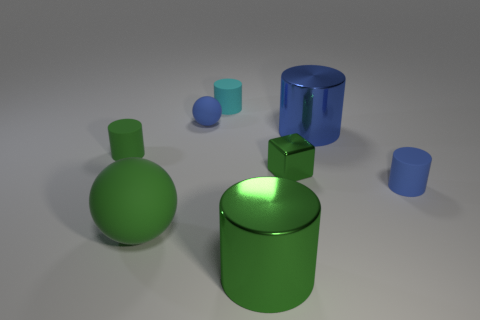Is there anything else that is the same shape as the small green metallic thing?
Make the answer very short. No. What number of blocks are either big blue shiny objects or shiny objects?
Your answer should be very brief. 1. What is the shape of the tiny green rubber object?
Provide a short and direct response. Cylinder. Are there any blue metallic things behind the cyan matte cylinder?
Ensure brevity in your answer.  No. Do the small cyan object and the small cylinder to the left of the cyan matte cylinder have the same material?
Your response must be concise. Yes. Does the big metal thing in front of the green rubber ball have the same shape as the large blue object?
Your answer should be very brief. Yes. What number of blocks are made of the same material as the big green sphere?
Make the answer very short. 0. How many objects are large cylinders that are right of the tiny green block or cyan matte cylinders?
Your answer should be very brief. 2. What size is the blue rubber sphere?
Offer a terse response. Small. What material is the tiny blue object on the left side of the matte cylinder that is behind the tiny blue rubber sphere made of?
Your answer should be very brief. Rubber. 